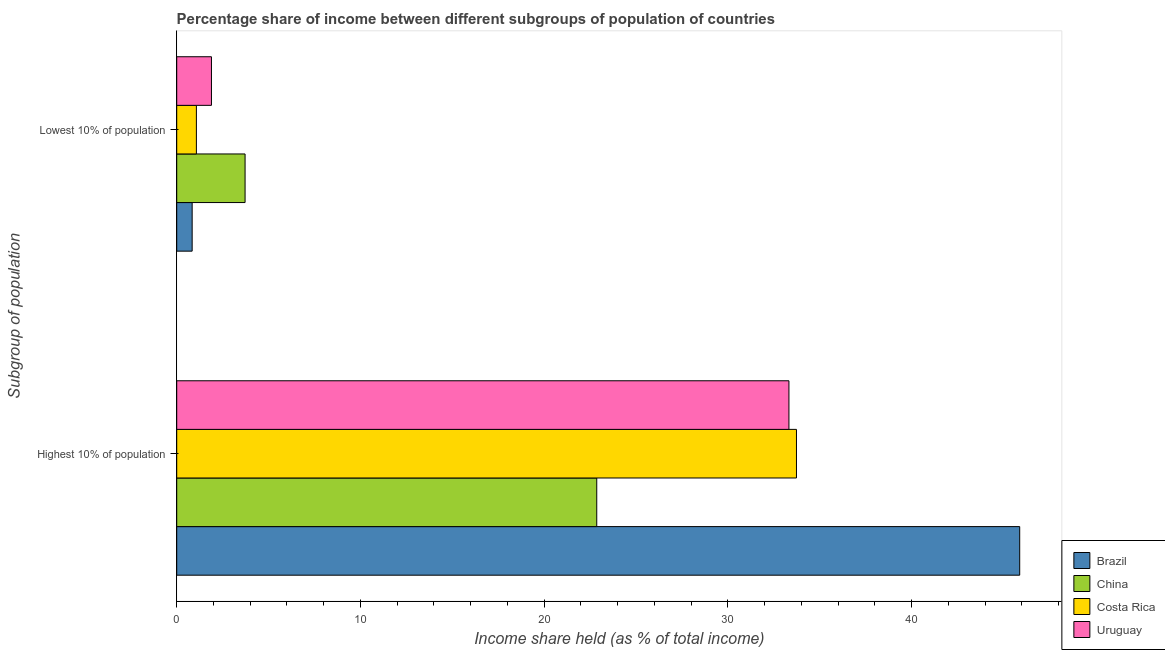How many different coloured bars are there?
Your answer should be very brief. 4. How many bars are there on the 2nd tick from the bottom?
Ensure brevity in your answer.  4. What is the label of the 2nd group of bars from the top?
Ensure brevity in your answer.  Highest 10% of population. What is the income share held by highest 10% of the population in Costa Rica?
Your answer should be compact. 33.73. Across all countries, what is the maximum income share held by lowest 10% of the population?
Give a very brief answer. 3.72. Across all countries, what is the minimum income share held by lowest 10% of the population?
Offer a very short reply. 0.84. In which country was the income share held by lowest 10% of the population maximum?
Your answer should be very brief. China. In which country was the income share held by highest 10% of the population minimum?
Provide a succinct answer. China. What is the total income share held by highest 10% of the population in the graph?
Your answer should be very brief. 135.79. What is the difference between the income share held by highest 10% of the population in Costa Rica and that in Uruguay?
Make the answer very short. 0.41. What is the difference between the income share held by highest 10% of the population in Uruguay and the income share held by lowest 10% of the population in Brazil?
Make the answer very short. 32.48. What is the average income share held by lowest 10% of the population per country?
Offer a terse response. 1.88. What is the difference between the income share held by lowest 10% of the population and income share held by highest 10% of the population in Uruguay?
Your answer should be very brief. -31.43. What is the ratio of the income share held by lowest 10% of the population in Costa Rica to that in Brazil?
Offer a very short reply. 1.27. What does the 2nd bar from the top in Highest 10% of population represents?
Offer a terse response. Costa Rica. What does the 1st bar from the bottom in Highest 10% of population represents?
Offer a terse response. Brazil. How many bars are there?
Give a very brief answer. 8. Are all the bars in the graph horizontal?
Your answer should be compact. Yes. What is the difference between two consecutive major ticks on the X-axis?
Offer a terse response. 10. Are the values on the major ticks of X-axis written in scientific E-notation?
Provide a succinct answer. No. How are the legend labels stacked?
Offer a very short reply. Vertical. What is the title of the graph?
Offer a terse response. Percentage share of income between different subgroups of population of countries. Does "Europe(developing only)" appear as one of the legend labels in the graph?
Offer a very short reply. No. What is the label or title of the X-axis?
Your response must be concise. Income share held (as % of total income). What is the label or title of the Y-axis?
Keep it short and to the point. Subgroup of population. What is the Income share held (as % of total income) of Brazil in Highest 10% of population?
Your answer should be compact. 45.88. What is the Income share held (as % of total income) in China in Highest 10% of population?
Give a very brief answer. 22.86. What is the Income share held (as % of total income) of Costa Rica in Highest 10% of population?
Your response must be concise. 33.73. What is the Income share held (as % of total income) of Uruguay in Highest 10% of population?
Provide a succinct answer. 33.32. What is the Income share held (as % of total income) of Brazil in Lowest 10% of population?
Offer a very short reply. 0.84. What is the Income share held (as % of total income) of China in Lowest 10% of population?
Your response must be concise. 3.72. What is the Income share held (as % of total income) in Costa Rica in Lowest 10% of population?
Your answer should be compact. 1.07. What is the Income share held (as % of total income) of Uruguay in Lowest 10% of population?
Provide a short and direct response. 1.89. Across all Subgroup of population, what is the maximum Income share held (as % of total income) in Brazil?
Ensure brevity in your answer.  45.88. Across all Subgroup of population, what is the maximum Income share held (as % of total income) of China?
Offer a very short reply. 22.86. Across all Subgroup of population, what is the maximum Income share held (as % of total income) in Costa Rica?
Offer a terse response. 33.73. Across all Subgroup of population, what is the maximum Income share held (as % of total income) of Uruguay?
Keep it short and to the point. 33.32. Across all Subgroup of population, what is the minimum Income share held (as % of total income) of Brazil?
Make the answer very short. 0.84. Across all Subgroup of population, what is the minimum Income share held (as % of total income) of China?
Give a very brief answer. 3.72. Across all Subgroup of population, what is the minimum Income share held (as % of total income) in Costa Rica?
Offer a terse response. 1.07. Across all Subgroup of population, what is the minimum Income share held (as % of total income) in Uruguay?
Provide a succinct answer. 1.89. What is the total Income share held (as % of total income) of Brazil in the graph?
Ensure brevity in your answer.  46.72. What is the total Income share held (as % of total income) of China in the graph?
Ensure brevity in your answer.  26.58. What is the total Income share held (as % of total income) in Costa Rica in the graph?
Keep it short and to the point. 34.8. What is the total Income share held (as % of total income) in Uruguay in the graph?
Keep it short and to the point. 35.21. What is the difference between the Income share held (as % of total income) of Brazil in Highest 10% of population and that in Lowest 10% of population?
Keep it short and to the point. 45.04. What is the difference between the Income share held (as % of total income) in China in Highest 10% of population and that in Lowest 10% of population?
Give a very brief answer. 19.14. What is the difference between the Income share held (as % of total income) of Costa Rica in Highest 10% of population and that in Lowest 10% of population?
Provide a succinct answer. 32.66. What is the difference between the Income share held (as % of total income) in Uruguay in Highest 10% of population and that in Lowest 10% of population?
Ensure brevity in your answer.  31.43. What is the difference between the Income share held (as % of total income) in Brazil in Highest 10% of population and the Income share held (as % of total income) in China in Lowest 10% of population?
Offer a terse response. 42.16. What is the difference between the Income share held (as % of total income) of Brazil in Highest 10% of population and the Income share held (as % of total income) of Costa Rica in Lowest 10% of population?
Offer a very short reply. 44.81. What is the difference between the Income share held (as % of total income) of Brazil in Highest 10% of population and the Income share held (as % of total income) of Uruguay in Lowest 10% of population?
Offer a terse response. 43.99. What is the difference between the Income share held (as % of total income) of China in Highest 10% of population and the Income share held (as % of total income) of Costa Rica in Lowest 10% of population?
Provide a short and direct response. 21.79. What is the difference between the Income share held (as % of total income) of China in Highest 10% of population and the Income share held (as % of total income) of Uruguay in Lowest 10% of population?
Ensure brevity in your answer.  20.97. What is the difference between the Income share held (as % of total income) in Costa Rica in Highest 10% of population and the Income share held (as % of total income) in Uruguay in Lowest 10% of population?
Keep it short and to the point. 31.84. What is the average Income share held (as % of total income) of Brazil per Subgroup of population?
Provide a short and direct response. 23.36. What is the average Income share held (as % of total income) of China per Subgroup of population?
Your answer should be very brief. 13.29. What is the average Income share held (as % of total income) in Costa Rica per Subgroup of population?
Your response must be concise. 17.4. What is the average Income share held (as % of total income) of Uruguay per Subgroup of population?
Your answer should be compact. 17.61. What is the difference between the Income share held (as % of total income) in Brazil and Income share held (as % of total income) in China in Highest 10% of population?
Your answer should be very brief. 23.02. What is the difference between the Income share held (as % of total income) of Brazil and Income share held (as % of total income) of Costa Rica in Highest 10% of population?
Provide a succinct answer. 12.15. What is the difference between the Income share held (as % of total income) of Brazil and Income share held (as % of total income) of Uruguay in Highest 10% of population?
Your answer should be compact. 12.56. What is the difference between the Income share held (as % of total income) in China and Income share held (as % of total income) in Costa Rica in Highest 10% of population?
Provide a succinct answer. -10.87. What is the difference between the Income share held (as % of total income) in China and Income share held (as % of total income) in Uruguay in Highest 10% of population?
Ensure brevity in your answer.  -10.46. What is the difference between the Income share held (as % of total income) in Costa Rica and Income share held (as % of total income) in Uruguay in Highest 10% of population?
Your answer should be compact. 0.41. What is the difference between the Income share held (as % of total income) in Brazil and Income share held (as % of total income) in China in Lowest 10% of population?
Your answer should be very brief. -2.88. What is the difference between the Income share held (as % of total income) of Brazil and Income share held (as % of total income) of Costa Rica in Lowest 10% of population?
Keep it short and to the point. -0.23. What is the difference between the Income share held (as % of total income) of Brazil and Income share held (as % of total income) of Uruguay in Lowest 10% of population?
Your answer should be very brief. -1.05. What is the difference between the Income share held (as % of total income) of China and Income share held (as % of total income) of Costa Rica in Lowest 10% of population?
Offer a very short reply. 2.65. What is the difference between the Income share held (as % of total income) of China and Income share held (as % of total income) of Uruguay in Lowest 10% of population?
Make the answer very short. 1.83. What is the difference between the Income share held (as % of total income) in Costa Rica and Income share held (as % of total income) in Uruguay in Lowest 10% of population?
Provide a succinct answer. -0.82. What is the ratio of the Income share held (as % of total income) in Brazil in Highest 10% of population to that in Lowest 10% of population?
Your answer should be compact. 54.62. What is the ratio of the Income share held (as % of total income) of China in Highest 10% of population to that in Lowest 10% of population?
Make the answer very short. 6.15. What is the ratio of the Income share held (as % of total income) of Costa Rica in Highest 10% of population to that in Lowest 10% of population?
Ensure brevity in your answer.  31.52. What is the ratio of the Income share held (as % of total income) of Uruguay in Highest 10% of population to that in Lowest 10% of population?
Ensure brevity in your answer.  17.63. What is the difference between the highest and the second highest Income share held (as % of total income) in Brazil?
Your response must be concise. 45.04. What is the difference between the highest and the second highest Income share held (as % of total income) in China?
Offer a terse response. 19.14. What is the difference between the highest and the second highest Income share held (as % of total income) in Costa Rica?
Offer a very short reply. 32.66. What is the difference between the highest and the second highest Income share held (as % of total income) of Uruguay?
Keep it short and to the point. 31.43. What is the difference between the highest and the lowest Income share held (as % of total income) in Brazil?
Ensure brevity in your answer.  45.04. What is the difference between the highest and the lowest Income share held (as % of total income) in China?
Provide a succinct answer. 19.14. What is the difference between the highest and the lowest Income share held (as % of total income) in Costa Rica?
Your answer should be very brief. 32.66. What is the difference between the highest and the lowest Income share held (as % of total income) in Uruguay?
Offer a very short reply. 31.43. 